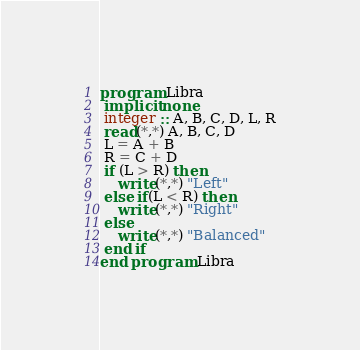<code> <loc_0><loc_0><loc_500><loc_500><_FORTRAN_>program Libra
 implicit none
 integer :: A, B, C, D, L, R
 read(*,*) A, B, C, D
 L = A + B
 R = C + D
 if (L > R) then
 	write(*,*) "Left"
 else if(L < R) then
 	write(*,*) "Right"
 else 
 	write(*,*) "Balanced"
 end if
end program Libra</code> 